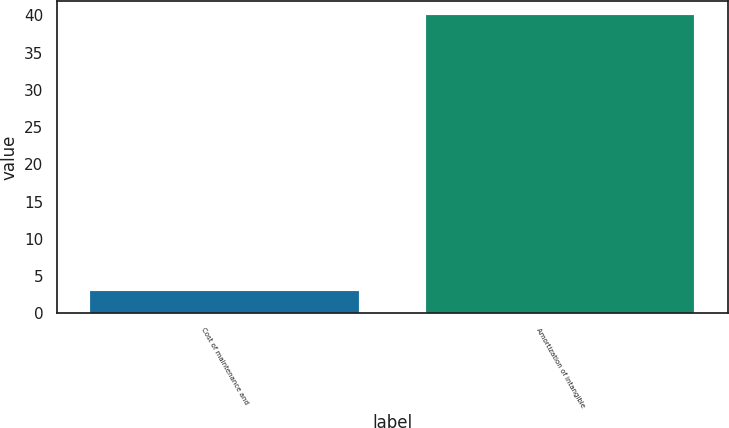Convert chart to OTSL. <chart><loc_0><loc_0><loc_500><loc_500><bar_chart><fcel>Cost of maintenance and<fcel>Amortization of intangible<nl><fcel>3<fcel>40<nl></chart> 